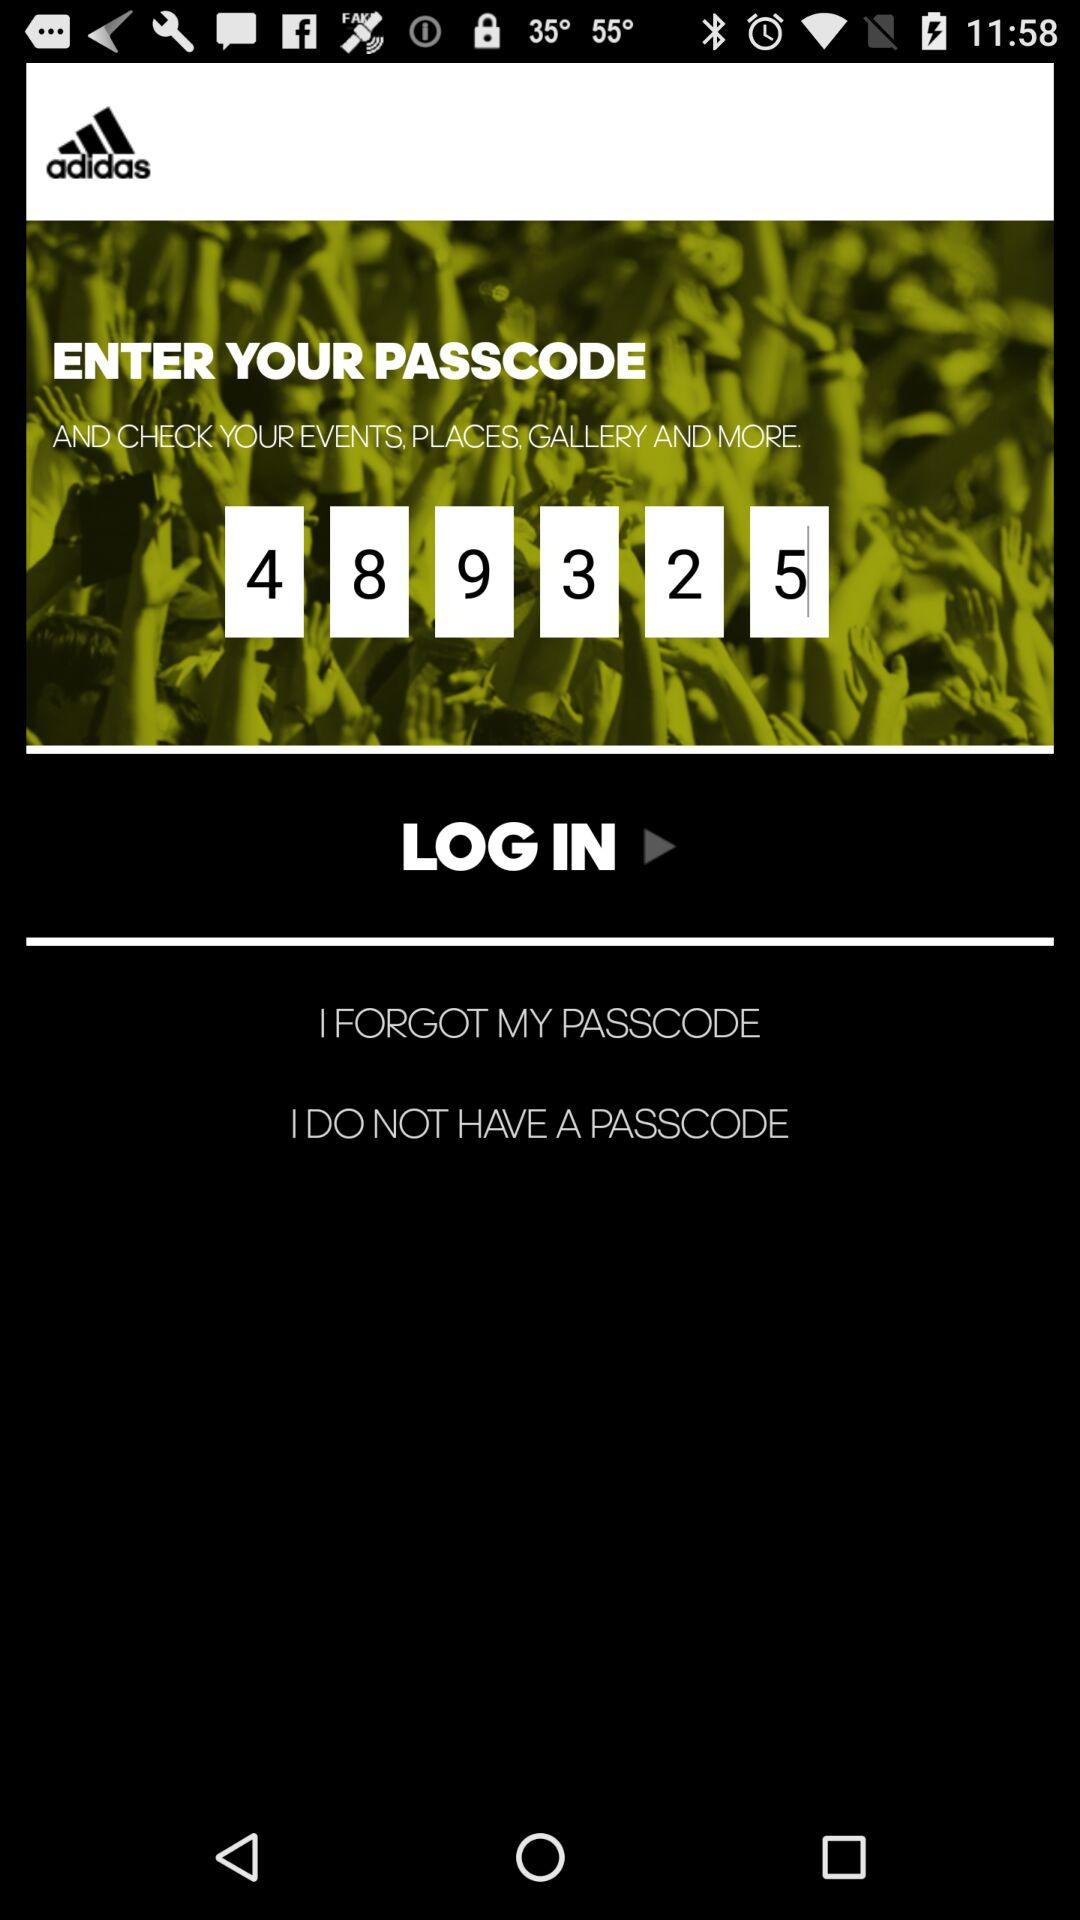What is the passcode? The passcode is 489325. 